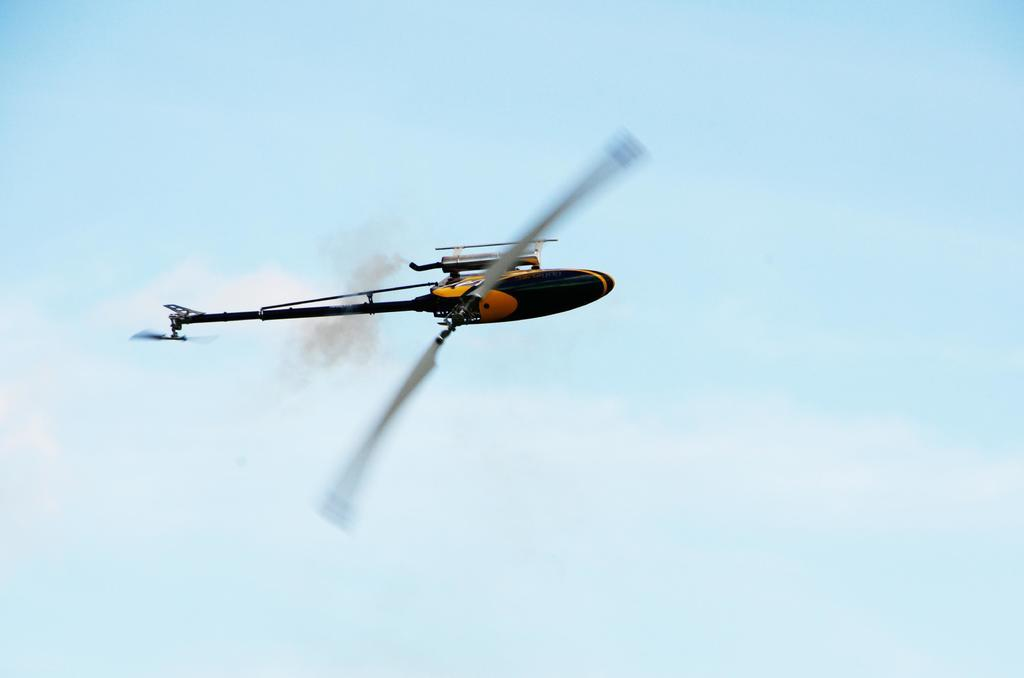Where was the image taken? The image was taken outdoors. What can be seen in the background of the image? There is the sky with clouds in the background. What is the main subject of the image? A toy chopper is flying in the air in the middle of the image? How does the toy chopper measure the throat of the clouds in the image? The toy chopper does not measure the throat of the clouds in the image, as it is a toy and not capable of such actions. 